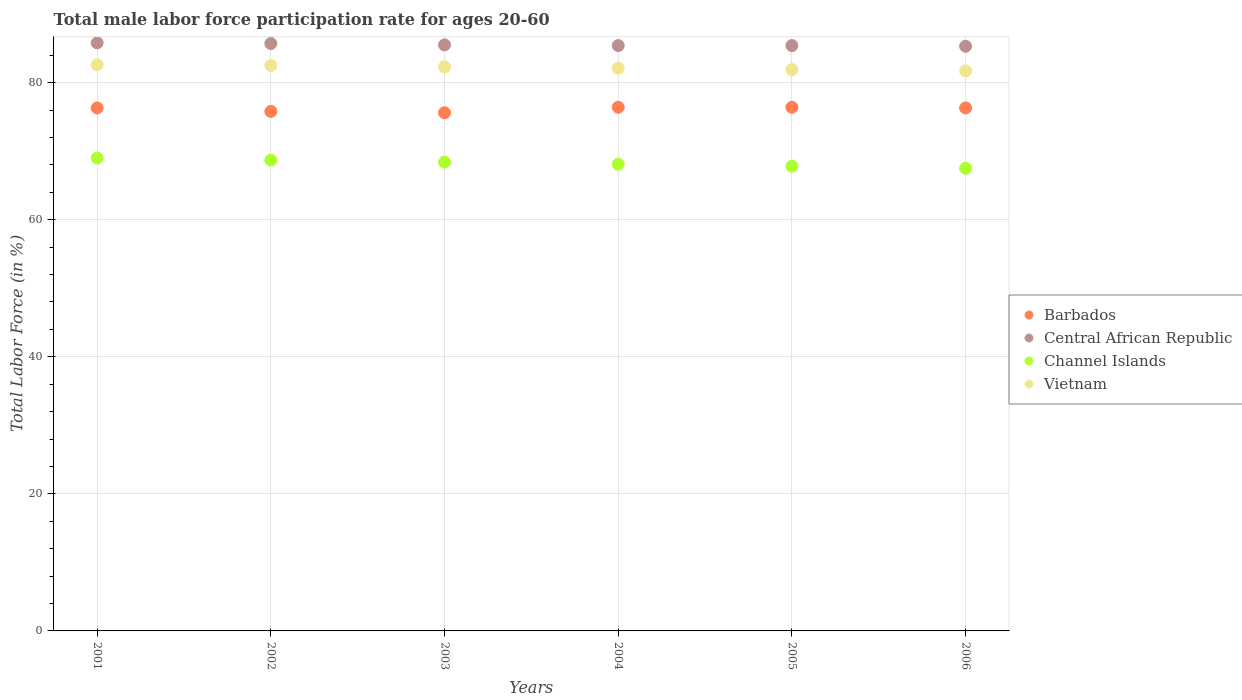Is the number of dotlines equal to the number of legend labels?
Provide a succinct answer. Yes. What is the male labor force participation rate in Vietnam in 2006?
Ensure brevity in your answer.  81.7. Across all years, what is the minimum male labor force participation rate in Central African Republic?
Ensure brevity in your answer.  85.3. In which year was the male labor force participation rate in Vietnam maximum?
Your answer should be very brief. 2001. What is the total male labor force participation rate in Barbados in the graph?
Provide a succinct answer. 456.8. What is the difference between the male labor force participation rate in Vietnam in 2003 and that in 2005?
Your response must be concise. 0.4. What is the difference between the male labor force participation rate in Channel Islands in 2002 and the male labor force participation rate in Vietnam in 2003?
Your answer should be very brief. -13.6. What is the average male labor force participation rate in Channel Islands per year?
Make the answer very short. 68.25. In the year 2002, what is the difference between the male labor force participation rate in Vietnam and male labor force participation rate in Channel Islands?
Keep it short and to the point. 13.8. In how many years, is the male labor force participation rate in Channel Islands greater than 60 %?
Ensure brevity in your answer.  6. What is the ratio of the male labor force participation rate in Central African Republic in 2002 to that in 2003?
Make the answer very short. 1. Is the male labor force participation rate in Vietnam in 2001 less than that in 2003?
Your answer should be compact. No. Is the difference between the male labor force participation rate in Vietnam in 2003 and 2004 greater than the difference between the male labor force participation rate in Channel Islands in 2003 and 2004?
Your answer should be very brief. No. What is the difference between the highest and the second highest male labor force participation rate in Central African Republic?
Your answer should be compact. 0.1. What is the difference between the highest and the lowest male labor force participation rate in Barbados?
Give a very brief answer. 0.8. Is it the case that in every year, the sum of the male labor force participation rate in Central African Republic and male labor force participation rate in Vietnam  is greater than the male labor force participation rate in Barbados?
Provide a succinct answer. Yes. Is the male labor force participation rate in Channel Islands strictly greater than the male labor force participation rate in Barbados over the years?
Ensure brevity in your answer.  No. How many years are there in the graph?
Ensure brevity in your answer.  6. What is the difference between two consecutive major ticks on the Y-axis?
Offer a terse response. 20. Where does the legend appear in the graph?
Your response must be concise. Center right. How are the legend labels stacked?
Your response must be concise. Vertical. What is the title of the graph?
Your answer should be compact. Total male labor force participation rate for ages 20-60. Does "Benin" appear as one of the legend labels in the graph?
Provide a succinct answer. No. What is the Total Labor Force (in %) in Barbados in 2001?
Your response must be concise. 76.3. What is the Total Labor Force (in %) in Central African Republic in 2001?
Your answer should be compact. 85.8. What is the Total Labor Force (in %) in Channel Islands in 2001?
Provide a succinct answer. 69. What is the Total Labor Force (in %) in Vietnam in 2001?
Give a very brief answer. 82.6. What is the Total Labor Force (in %) in Barbados in 2002?
Keep it short and to the point. 75.8. What is the Total Labor Force (in %) in Central African Republic in 2002?
Provide a succinct answer. 85.7. What is the Total Labor Force (in %) of Channel Islands in 2002?
Your response must be concise. 68.7. What is the Total Labor Force (in %) in Vietnam in 2002?
Your response must be concise. 82.5. What is the Total Labor Force (in %) in Barbados in 2003?
Keep it short and to the point. 75.6. What is the Total Labor Force (in %) of Central African Republic in 2003?
Give a very brief answer. 85.5. What is the Total Labor Force (in %) in Channel Islands in 2003?
Your answer should be very brief. 68.4. What is the Total Labor Force (in %) of Vietnam in 2003?
Provide a succinct answer. 82.3. What is the Total Labor Force (in %) of Barbados in 2004?
Ensure brevity in your answer.  76.4. What is the Total Labor Force (in %) in Central African Republic in 2004?
Your response must be concise. 85.4. What is the Total Labor Force (in %) of Channel Islands in 2004?
Provide a succinct answer. 68.1. What is the Total Labor Force (in %) in Vietnam in 2004?
Your answer should be compact. 82.1. What is the Total Labor Force (in %) in Barbados in 2005?
Provide a succinct answer. 76.4. What is the Total Labor Force (in %) of Central African Republic in 2005?
Ensure brevity in your answer.  85.4. What is the Total Labor Force (in %) in Channel Islands in 2005?
Ensure brevity in your answer.  67.8. What is the Total Labor Force (in %) of Vietnam in 2005?
Ensure brevity in your answer.  81.9. What is the Total Labor Force (in %) in Barbados in 2006?
Offer a terse response. 76.3. What is the Total Labor Force (in %) of Central African Republic in 2006?
Ensure brevity in your answer.  85.3. What is the Total Labor Force (in %) of Channel Islands in 2006?
Your answer should be compact. 67.5. What is the Total Labor Force (in %) in Vietnam in 2006?
Offer a very short reply. 81.7. Across all years, what is the maximum Total Labor Force (in %) in Barbados?
Your answer should be compact. 76.4. Across all years, what is the maximum Total Labor Force (in %) of Central African Republic?
Offer a terse response. 85.8. Across all years, what is the maximum Total Labor Force (in %) in Channel Islands?
Give a very brief answer. 69. Across all years, what is the maximum Total Labor Force (in %) in Vietnam?
Keep it short and to the point. 82.6. Across all years, what is the minimum Total Labor Force (in %) in Barbados?
Offer a very short reply. 75.6. Across all years, what is the minimum Total Labor Force (in %) in Central African Republic?
Your answer should be compact. 85.3. Across all years, what is the minimum Total Labor Force (in %) of Channel Islands?
Provide a succinct answer. 67.5. Across all years, what is the minimum Total Labor Force (in %) in Vietnam?
Keep it short and to the point. 81.7. What is the total Total Labor Force (in %) in Barbados in the graph?
Ensure brevity in your answer.  456.8. What is the total Total Labor Force (in %) of Central African Republic in the graph?
Your answer should be compact. 513.1. What is the total Total Labor Force (in %) in Channel Islands in the graph?
Your answer should be compact. 409.5. What is the total Total Labor Force (in %) of Vietnam in the graph?
Ensure brevity in your answer.  493.1. What is the difference between the Total Labor Force (in %) in Central African Republic in 2001 and that in 2003?
Offer a very short reply. 0.3. What is the difference between the Total Labor Force (in %) of Channel Islands in 2001 and that in 2003?
Keep it short and to the point. 0.6. What is the difference between the Total Labor Force (in %) of Barbados in 2001 and that in 2004?
Offer a very short reply. -0.1. What is the difference between the Total Labor Force (in %) of Central African Republic in 2001 and that in 2004?
Provide a short and direct response. 0.4. What is the difference between the Total Labor Force (in %) of Channel Islands in 2001 and that in 2004?
Keep it short and to the point. 0.9. What is the difference between the Total Labor Force (in %) in Barbados in 2001 and that in 2005?
Give a very brief answer. -0.1. What is the difference between the Total Labor Force (in %) of Channel Islands in 2001 and that in 2005?
Provide a short and direct response. 1.2. What is the difference between the Total Labor Force (in %) in Vietnam in 2001 and that in 2005?
Provide a succinct answer. 0.7. What is the difference between the Total Labor Force (in %) in Central African Republic in 2001 and that in 2006?
Your answer should be very brief. 0.5. What is the difference between the Total Labor Force (in %) of Vietnam in 2001 and that in 2006?
Ensure brevity in your answer.  0.9. What is the difference between the Total Labor Force (in %) in Central African Republic in 2002 and that in 2004?
Your answer should be very brief. 0.3. What is the difference between the Total Labor Force (in %) of Channel Islands in 2002 and that in 2004?
Make the answer very short. 0.6. What is the difference between the Total Labor Force (in %) of Vietnam in 2002 and that in 2004?
Give a very brief answer. 0.4. What is the difference between the Total Labor Force (in %) of Central African Republic in 2002 and that in 2005?
Your response must be concise. 0.3. What is the difference between the Total Labor Force (in %) of Channel Islands in 2002 and that in 2006?
Your response must be concise. 1.2. What is the difference between the Total Labor Force (in %) in Barbados in 2003 and that in 2004?
Your response must be concise. -0.8. What is the difference between the Total Labor Force (in %) in Channel Islands in 2003 and that in 2004?
Keep it short and to the point. 0.3. What is the difference between the Total Labor Force (in %) in Vietnam in 2003 and that in 2004?
Ensure brevity in your answer.  0.2. What is the difference between the Total Labor Force (in %) in Central African Republic in 2003 and that in 2005?
Make the answer very short. 0.1. What is the difference between the Total Labor Force (in %) of Vietnam in 2003 and that in 2006?
Offer a terse response. 0.6. What is the difference between the Total Labor Force (in %) in Barbados in 2004 and that in 2005?
Make the answer very short. 0. What is the difference between the Total Labor Force (in %) in Central African Republic in 2004 and that in 2005?
Ensure brevity in your answer.  0. What is the difference between the Total Labor Force (in %) of Channel Islands in 2004 and that in 2005?
Ensure brevity in your answer.  0.3. What is the difference between the Total Labor Force (in %) of Vietnam in 2004 and that in 2005?
Offer a terse response. 0.2. What is the difference between the Total Labor Force (in %) of Barbados in 2004 and that in 2006?
Provide a succinct answer. 0.1. What is the difference between the Total Labor Force (in %) of Channel Islands in 2004 and that in 2006?
Keep it short and to the point. 0.6. What is the difference between the Total Labor Force (in %) in Vietnam in 2004 and that in 2006?
Provide a short and direct response. 0.4. What is the difference between the Total Labor Force (in %) of Barbados in 2005 and that in 2006?
Provide a short and direct response. 0.1. What is the difference between the Total Labor Force (in %) of Channel Islands in 2005 and that in 2006?
Make the answer very short. 0.3. What is the difference between the Total Labor Force (in %) of Vietnam in 2005 and that in 2006?
Provide a succinct answer. 0.2. What is the difference between the Total Labor Force (in %) of Barbados in 2001 and the Total Labor Force (in %) of Central African Republic in 2002?
Your response must be concise. -9.4. What is the difference between the Total Labor Force (in %) of Barbados in 2001 and the Total Labor Force (in %) of Channel Islands in 2002?
Ensure brevity in your answer.  7.6. What is the difference between the Total Labor Force (in %) of Central African Republic in 2001 and the Total Labor Force (in %) of Vietnam in 2002?
Ensure brevity in your answer.  3.3. What is the difference between the Total Labor Force (in %) in Channel Islands in 2001 and the Total Labor Force (in %) in Vietnam in 2002?
Ensure brevity in your answer.  -13.5. What is the difference between the Total Labor Force (in %) in Barbados in 2001 and the Total Labor Force (in %) in Channel Islands in 2003?
Your answer should be very brief. 7.9. What is the difference between the Total Labor Force (in %) in Central African Republic in 2001 and the Total Labor Force (in %) in Channel Islands in 2003?
Offer a terse response. 17.4. What is the difference between the Total Labor Force (in %) of Central African Republic in 2001 and the Total Labor Force (in %) of Vietnam in 2003?
Provide a succinct answer. 3.5. What is the difference between the Total Labor Force (in %) of Barbados in 2001 and the Total Labor Force (in %) of Central African Republic in 2004?
Your answer should be very brief. -9.1. What is the difference between the Total Labor Force (in %) of Barbados in 2001 and the Total Labor Force (in %) of Channel Islands in 2004?
Keep it short and to the point. 8.2. What is the difference between the Total Labor Force (in %) of Barbados in 2001 and the Total Labor Force (in %) of Vietnam in 2004?
Offer a terse response. -5.8. What is the difference between the Total Labor Force (in %) of Barbados in 2001 and the Total Labor Force (in %) of Channel Islands in 2005?
Your answer should be compact. 8.5. What is the difference between the Total Labor Force (in %) of Barbados in 2001 and the Total Labor Force (in %) of Vietnam in 2005?
Your answer should be compact. -5.6. What is the difference between the Total Labor Force (in %) of Central African Republic in 2001 and the Total Labor Force (in %) of Channel Islands in 2005?
Give a very brief answer. 18. What is the difference between the Total Labor Force (in %) in Central African Republic in 2001 and the Total Labor Force (in %) in Vietnam in 2005?
Offer a very short reply. 3.9. What is the difference between the Total Labor Force (in %) in Channel Islands in 2001 and the Total Labor Force (in %) in Vietnam in 2005?
Make the answer very short. -12.9. What is the difference between the Total Labor Force (in %) of Barbados in 2001 and the Total Labor Force (in %) of Channel Islands in 2006?
Keep it short and to the point. 8.8. What is the difference between the Total Labor Force (in %) in Central African Republic in 2001 and the Total Labor Force (in %) in Channel Islands in 2006?
Provide a short and direct response. 18.3. What is the difference between the Total Labor Force (in %) in Central African Republic in 2001 and the Total Labor Force (in %) in Vietnam in 2006?
Provide a succinct answer. 4.1. What is the difference between the Total Labor Force (in %) in Central African Republic in 2002 and the Total Labor Force (in %) in Channel Islands in 2003?
Offer a very short reply. 17.3. What is the difference between the Total Labor Force (in %) of Central African Republic in 2002 and the Total Labor Force (in %) of Vietnam in 2003?
Your response must be concise. 3.4. What is the difference between the Total Labor Force (in %) of Barbados in 2002 and the Total Labor Force (in %) of Central African Republic in 2004?
Provide a short and direct response. -9.6. What is the difference between the Total Labor Force (in %) of Barbados in 2002 and the Total Labor Force (in %) of Channel Islands in 2004?
Offer a very short reply. 7.7. What is the difference between the Total Labor Force (in %) of Channel Islands in 2002 and the Total Labor Force (in %) of Vietnam in 2004?
Provide a short and direct response. -13.4. What is the difference between the Total Labor Force (in %) in Barbados in 2002 and the Total Labor Force (in %) in Central African Republic in 2005?
Your response must be concise. -9.6. What is the difference between the Total Labor Force (in %) of Barbados in 2002 and the Total Labor Force (in %) of Channel Islands in 2005?
Give a very brief answer. 8. What is the difference between the Total Labor Force (in %) in Central African Republic in 2002 and the Total Labor Force (in %) in Channel Islands in 2005?
Offer a terse response. 17.9. What is the difference between the Total Labor Force (in %) of Central African Republic in 2002 and the Total Labor Force (in %) of Vietnam in 2005?
Keep it short and to the point. 3.8. What is the difference between the Total Labor Force (in %) of Barbados in 2002 and the Total Labor Force (in %) of Channel Islands in 2006?
Give a very brief answer. 8.3. What is the difference between the Total Labor Force (in %) in Central African Republic in 2002 and the Total Labor Force (in %) in Channel Islands in 2006?
Provide a succinct answer. 18.2. What is the difference between the Total Labor Force (in %) in Central African Republic in 2002 and the Total Labor Force (in %) in Vietnam in 2006?
Offer a terse response. 4. What is the difference between the Total Labor Force (in %) of Barbados in 2003 and the Total Labor Force (in %) of Channel Islands in 2004?
Your answer should be very brief. 7.5. What is the difference between the Total Labor Force (in %) in Channel Islands in 2003 and the Total Labor Force (in %) in Vietnam in 2004?
Ensure brevity in your answer.  -13.7. What is the difference between the Total Labor Force (in %) of Barbados in 2003 and the Total Labor Force (in %) of Central African Republic in 2005?
Your answer should be compact. -9.8. What is the difference between the Total Labor Force (in %) of Central African Republic in 2003 and the Total Labor Force (in %) of Channel Islands in 2005?
Give a very brief answer. 17.7. What is the difference between the Total Labor Force (in %) in Channel Islands in 2003 and the Total Labor Force (in %) in Vietnam in 2005?
Offer a terse response. -13.5. What is the difference between the Total Labor Force (in %) in Barbados in 2003 and the Total Labor Force (in %) in Vietnam in 2006?
Offer a very short reply. -6.1. What is the difference between the Total Labor Force (in %) in Central African Republic in 2003 and the Total Labor Force (in %) in Channel Islands in 2006?
Give a very brief answer. 18. What is the difference between the Total Labor Force (in %) in Channel Islands in 2003 and the Total Labor Force (in %) in Vietnam in 2006?
Give a very brief answer. -13.3. What is the difference between the Total Labor Force (in %) in Barbados in 2004 and the Total Labor Force (in %) in Central African Republic in 2005?
Give a very brief answer. -9. What is the difference between the Total Labor Force (in %) of Barbados in 2004 and the Total Labor Force (in %) of Channel Islands in 2005?
Give a very brief answer. 8.6. What is the difference between the Total Labor Force (in %) in Barbados in 2004 and the Total Labor Force (in %) in Channel Islands in 2006?
Your answer should be compact. 8.9. What is the difference between the Total Labor Force (in %) of Central African Republic in 2004 and the Total Labor Force (in %) of Channel Islands in 2006?
Ensure brevity in your answer.  17.9. What is the difference between the Total Labor Force (in %) in Central African Republic in 2004 and the Total Labor Force (in %) in Vietnam in 2006?
Offer a very short reply. 3.7. What is the difference between the Total Labor Force (in %) of Channel Islands in 2004 and the Total Labor Force (in %) of Vietnam in 2006?
Your answer should be very brief. -13.6. What is the difference between the Total Labor Force (in %) of Barbados in 2005 and the Total Labor Force (in %) of Vietnam in 2006?
Offer a terse response. -5.3. What is the difference between the Total Labor Force (in %) of Channel Islands in 2005 and the Total Labor Force (in %) of Vietnam in 2006?
Your answer should be very brief. -13.9. What is the average Total Labor Force (in %) of Barbados per year?
Your response must be concise. 76.13. What is the average Total Labor Force (in %) of Central African Republic per year?
Ensure brevity in your answer.  85.52. What is the average Total Labor Force (in %) of Channel Islands per year?
Offer a very short reply. 68.25. What is the average Total Labor Force (in %) of Vietnam per year?
Offer a very short reply. 82.18. In the year 2001, what is the difference between the Total Labor Force (in %) in Barbados and Total Labor Force (in %) in Channel Islands?
Your answer should be very brief. 7.3. In the year 2001, what is the difference between the Total Labor Force (in %) in Barbados and Total Labor Force (in %) in Vietnam?
Make the answer very short. -6.3. In the year 2001, what is the difference between the Total Labor Force (in %) in Central African Republic and Total Labor Force (in %) in Channel Islands?
Keep it short and to the point. 16.8. In the year 2001, what is the difference between the Total Labor Force (in %) in Channel Islands and Total Labor Force (in %) in Vietnam?
Make the answer very short. -13.6. In the year 2002, what is the difference between the Total Labor Force (in %) in Barbados and Total Labor Force (in %) in Channel Islands?
Your answer should be very brief. 7.1. In the year 2003, what is the difference between the Total Labor Force (in %) in Barbados and Total Labor Force (in %) in Central African Republic?
Your answer should be compact. -9.9. In the year 2003, what is the difference between the Total Labor Force (in %) of Barbados and Total Labor Force (in %) of Channel Islands?
Provide a succinct answer. 7.2. In the year 2003, what is the difference between the Total Labor Force (in %) in Barbados and Total Labor Force (in %) in Vietnam?
Ensure brevity in your answer.  -6.7. In the year 2003, what is the difference between the Total Labor Force (in %) in Central African Republic and Total Labor Force (in %) in Vietnam?
Provide a short and direct response. 3.2. In the year 2003, what is the difference between the Total Labor Force (in %) of Channel Islands and Total Labor Force (in %) of Vietnam?
Provide a succinct answer. -13.9. In the year 2004, what is the difference between the Total Labor Force (in %) of Barbados and Total Labor Force (in %) of Channel Islands?
Provide a short and direct response. 8.3. In the year 2004, what is the difference between the Total Labor Force (in %) of Barbados and Total Labor Force (in %) of Vietnam?
Provide a succinct answer. -5.7. In the year 2004, what is the difference between the Total Labor Force (in %) in Central African Republic and Total Labor Force (in %) in Vietnam?
Ensure brevity in your answer.  3.3. In the year 2004, what is the difference between the Total Labor Force (in %) in Channel Islands and Total Labor Force (in %) in Vietnam?
Give a very brief answer. -14. In the year 2005, what is the difference between the Total Labor Force (in %) in Barbados and Total Labor Force (in %) in Central African Republic?
Provide a short and direct response. -9. In the year 2005, what is the difference between the Total Labor Force (in %) in Central African Republic and Total Labor Force (in %) in Channel Islands?
Keep it short and to the point. 17.6. In the year 2005, what is the difference between the Total Labor Force (in %) in Central African Republic and Total Labor Force (in %) in Vietnam?
Provide a short and direct response. 3.5. In the year 2005, what is the difference between the Total Labor Force (in %) of Channel Islands and Total Labor Force (in %) of Vietnam?
Offer a very short reply. -14.1. In the year 2006, what is the difference between the Total Labor Force (in %) in Barbados and Total Labor Force (in %) in Vietnam?
Provide a succinct answer. -5.4. What is the ratio of the Total Labor Force (in %) of Barbados in 2001 to that in 2002?
Provide a succinct answer. 1.01. What is the ratio of the Total Labor Force (in %) of Central African Republic in 2001 to that in 2002?
Provide a succinct answer. 1. What is the ratio of the Total Labor Force (in %) in Channel Islands in 2001 to that in 2002?
Ensure brevity in your answer.  1. What is the ratio of the Total Labor Force (in %) of Barbados in 2001 to that in 2003?
Offer a very short reply. 1.01. What is the ratio of the Total Labor Force (in %) in Central African Republic in 2001 to that in 2003?
Offer a very short reply. 1. What is the ratio of the Total Labor Force (in %) in Channel Islands in 2001 to that in 2003?
Ensure brevity in your answer.  1.01. What is the ratio of the Total Labor Force (in %) in Vietnam in 2001 to that in 2003?
Keep it short and to the point. 1. What is the ratio of the Total Labor Force (in %) in Central African Republic in 2001 to that in 2004?
Make the answer very short. 1. What is the ratio of the Total Labor Force (in %) in Channel Islands in 2001 to that in 2004?
Your answer should be compact. 1.01. What is the ratio of the Total Labor Force (in %) in Barbados in 2001 to that in 2005?
Provide a succinct answer. 1. What is the ratio of the Total Labor Force (in %) of Channel Islands in 2001 to that in 2005?
Your response must be concise. 1.02. What is the ratio of the Total Labor Force (in %) in Vietnam in 2001 to that in 2005?
Your answer should be very brief. 1.01. What is the ratio of the Total Labor Force (in %) of Barbados in 2001 to that in 2006?
Provide a succinct answer. 1. What is the ratio of the Total Labor Force (in %) in Central African Republic in 2001 to that in 2006?
Give a very brief answer. 1.01. What is the ratio of the Total Labor Force (in %) of Channel Islands in 2001 to that in 2006?
Your answer should be compact. 1.02. What is the ratio of the Total Labor Force (in %) in Barbados in 2002 to that in 2003?
Offer a terse response. 1. What is the ratio of the Total Labor Force (in %) of Channel Islands in 2002 to that in 2003?
Offer a terse response. 1. What is the ratio of the Total Labor Force (in %) in Barbados in 2002 to that in 2004?
Keep it short and to the point. 0.99. What is the ratio of the Total Labor Force (in %) in Central African Republic in 2002 to that in 2004?
Make the answer very short. 1. What is the ratio of the Total Labor Force (in %) in Channel Islands in 2002 to that in 2004?
Provide a short and direct response. 1.01. What is the ratio of the Total Labor Force (in %) of Vietnam in 2002 to that in 2004?
Give a very brief answer. 1. What is the ratio of the Total Labor Force (in %) in Barbados in 2002 to that in 2005?
Provide a short and direct response. 0.99. What is the ratio of the Total Labor Force (in %) of Central African Republic in 2002 to that in 2005?
Your answer should be very brief. 1. What is the ratio of the Total Labor Force (in %) in Channel Islands in 2002 to that in 2005?
Offer a terse response. 1.01. What is the ratio of the Total Labor Force (in %) of Vietnam in 2002 to that in 2005?
Make the answer very short. 1.01. What is the ratio of the Total Labor Force (in %) in Barbados in 2002 to that in 2006?
Provide a succinct answer. 0.99. What is the ratio of the Total Labor Force (in %) in Central African Republic in 2002 to that in 2006?
Keep it short and to the point. 1. What is the ratio of the Total Labor Force (in %) in Channel Islands in 2002 to that in 2006?
Offer a very short reply. 1.02. What is the ratio of the Total Labor Force (in %) in Vietnam in 2002 to that in 2006?
Your answer should be very brief. 1.01. What is the ratio of the Total Labor Force (in %) in Barbados in 2003 to that in 2004?
Give a very brief answer. 0.99. What is the ratio of the Total Labor Force (in %) of Channel Islands in 2003 to that in 2004?
Make the answer very short. 1. What is the ratio of the Total Labor Force (in %) of Vietnam in 2003 to that in 2004?
Your answer should be compact. 1. What is the ratio of the Total Labor Force (in %) of Barbados in 2003 to that in 2005?
Ensure brevity in your answer.  0.99. What is the ratio of the Total Labor Force (in %) in Channel Islands in 2003 to that in 2005?
Keep it short and to the point. 1.01. What is the ratio of the Total Labor Force (in %) of Barbados in 2003 to that in 2006?
Your answer should be compact. 0.99. What is the ratio of the Total Labor Force (in %) of Channel Islands in 2003 to that in 2006?
Offer a terse response. 1.01. What is the ratio of the Total Labor Force (in %) of Vietnam in 2003 to that in 2006?
Give a very brief answer. 1.01. What is the ratio of the Total Labor Force (in %) of Barbados in 2004 to that in 2005?
Your answer should be compact. 1. What is the ratio of the Total Labor Force (in %) of Central African Republic in 2004 to that in 2005?
Your answer should be very brief. 1. What is the ratio of the Total Labor Force (in %) in Channel Islands in 2004 to that in 2005?
Your answer should be very brief. 1. What is the ratio of the Total Labor Force (in %) in Vietnam in 2004 to that in 2005?
Keep it short and to the point. 1. What is the ratio of the Total Labor Force (in %) of Channel Islands in 2004 to that in 2006?
Your response must be concise. 1.01. What is the ratio of the Total Labor Force (in %) of Central African Republic in 2005 to that in 2006?
Provide a short and direct response. 1. What is the difference between the highest and the second highest Total Labor Force (in %) of Channel Islands?
Give a very brief answer. 0.3. What is the difference between the highest and the lowest Total Labor Force (in %) of Barbados?
Your answer should be compact. 0.8. 